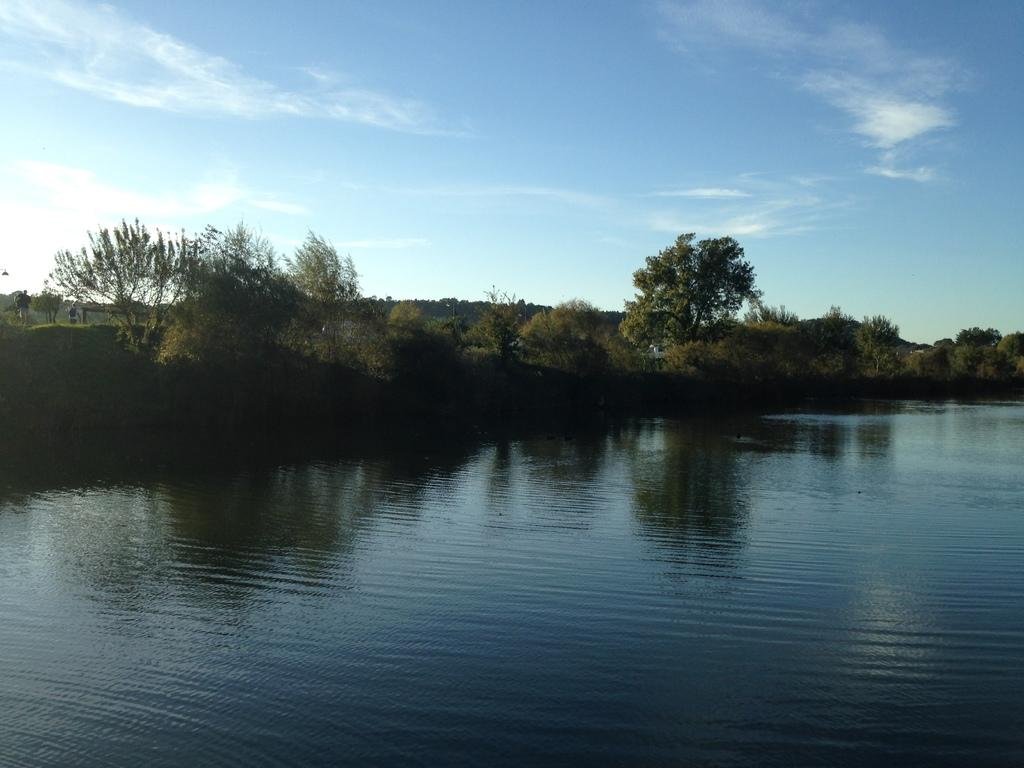What type of natural feature is present in the image? There is a river in the image. What other natural elements can be seen in the image? There are trees in the image. How many people are in the image? There are two people standing in the image. What is visible in the background of the image? The sky is visible in the background of the image. Where is the cave located in the image? There is no cave present in the image. What type of story is being told by the people in the image? There is no story being told in the image; it simply shows two people standing near a river and trees. 